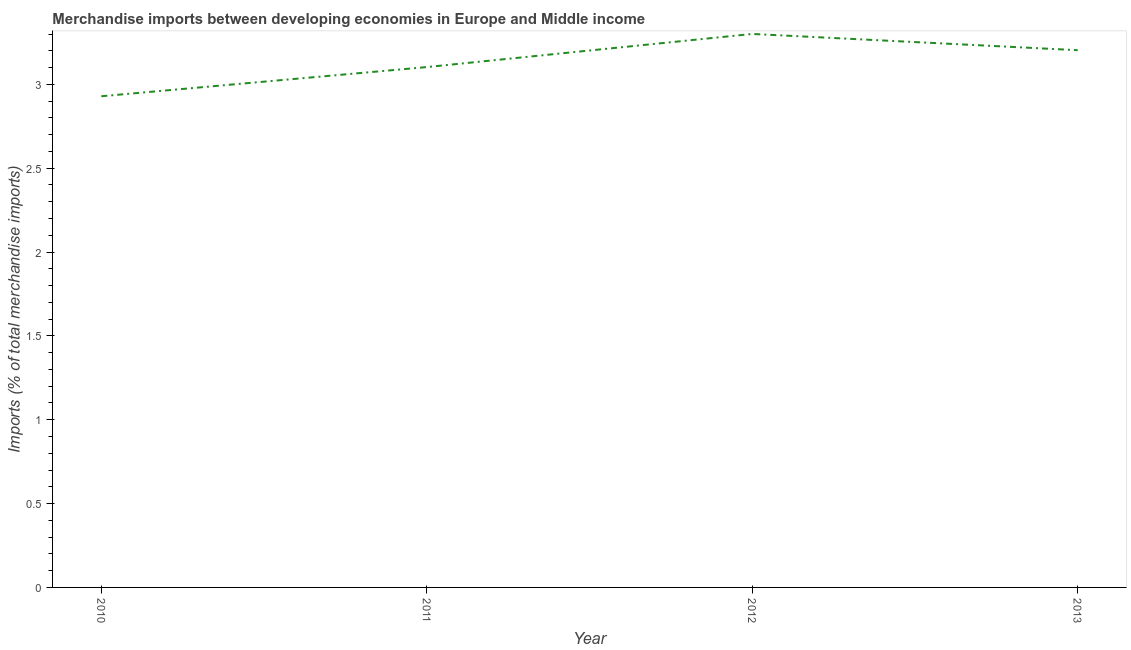What is the merchandise imports in 2012?
Keep it short and to the point. 3.3. Across all years, what is the maximum merchandise imports?
Your answer should be very brief. 3.3. Across all years, what is the minimum merchandise imports?
Offer a terse response. 2.93. In which year was the merchandise imports maximum?
Your answer should be compact. 2012. What is the sum of the merchandise imports?
Provide a short and direct response. 12.54. What is the difference between the merchandise imports in 2010 and 2013?
Offer a terse response. -0.27. What is the average merchandise imports per year?
Give a very brief answer. 3.13. What is the median merchandise imports?
Offer a terse response. 3.15. In how many years, is the merchandise imports greater than 2.3 %?
Make the answer very short. 4. What is the ratio of the merchandise imports in 2010 to that in 2012?
Provide a succinct answer. 0.89. What is the difference between the highest and the second highest merchandise imports?
Offer a terse response. 0.1. Is the sum of the merchandise imports in 2012 and 2013 greater than the maximum merchandise imports across all years?
Offer a very short reply. Yes. What is the difference between the highest and the lowest merchandise imports?
Ensure brevity in your answer.  0.37. In how many years, is the merchandise imports greater than the average merchandise imports taken over all years?
Offer a terse response. 2. How many lines are there?
Make the answer very short. 1. Does the graph contain any zero values?
Your answer should be very brief. No. What is the title of the graph?
Your answer should be compact. Merchandise imports between developing economies in Europe and Middle income. What is the label or title of the X-axis?
Your answer should be compact. Year. What is the label or title of the Y-axis?
Keep it short and to the point. Imports (% of total merchandise imports). What is the Imports (% of total merchandise imports) in 2010?
Ensure brevity in your answer.  2.93. What is the Imports (% of total merchandise imports) of 2011?
Your answer should be very brief. 3.1. What is the Imports (% of total merchandise imports) in 2012?
Your response must be concise. 3.3. What is the Imports (% of total merchandise imports) in 2013?
Keep it short and to the point. 3.2. What is the difference between the Imports (% of total merchandise imports) in 2010 and 2011?
Give a very brief answer. -0.17. What is the difference between the Imports (% of total merchandise imports) in 2010 and 2012?
Offer a terse response. -0.37. What is the difference between the Imports (% of total merchandise imports) in 2010 and 2013?
Keep it short and to the point. -0.27. What is the difference between the Imports (% of total merchandise imports) in 2011 and 2012?
Make the answer very short. -0.2. What is the difference between the Imports (% of total merchandise imports) in 2011 and 2013?
Your answer should be compact. -0.1. What is the difference between the Imports (% of total merchandise imports) in 2012 and 2013?
Give a very brief answer. 0.1. What is the ratio of the Imports (% of total merchandise imports) in 2010 to that in 2011?
Give a very brief answer. 0.94. What is the ratio of the Imports (% of total merchandise imports) in 2010 to that in 2012?
Give a very brief answer. 0.89. What is the ratio of the Imports (% of total merchandise imports) in 2010 to that in 2013?
Provide a succinct answer. 0.91. What is the ratio of the Imports (% of total merchandise imports) in 2012 to that in 2013?
Your answer should be compact. 1.03. 